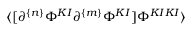Convert formula to latex. <formula><loc_0><loc_0><loc_500><loc_500>\langle [ \partial ^ { \{ n \} } \Phi ^ { K I } \partial ^ { \{ m \} } \Phi ^ { K I } ] \Phi ^ { K I K I } \rangle</formula> 